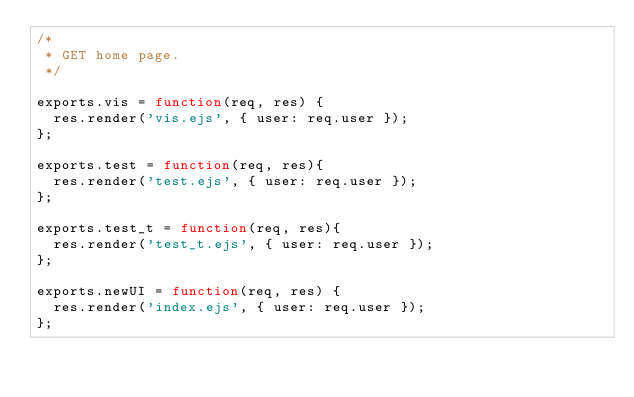<code> <loc_0><loc_0><loc_500><loc_500><_JavaScript_>/*
 * GET home page.
 */

exports.vis = function(req, res) {
	res.render('vis.ejs', { user: req.user });
};

exports.test = function(req, res){
	res.render('test.ejs', { user: req.user });
};

exports.test_t = function(req, res){
	res.render('test_t.ejs', { user: req.user });
};

exports.newUI = function(req, res) {
	res.render('index.ejs', { user: req.user });
};
</code> 